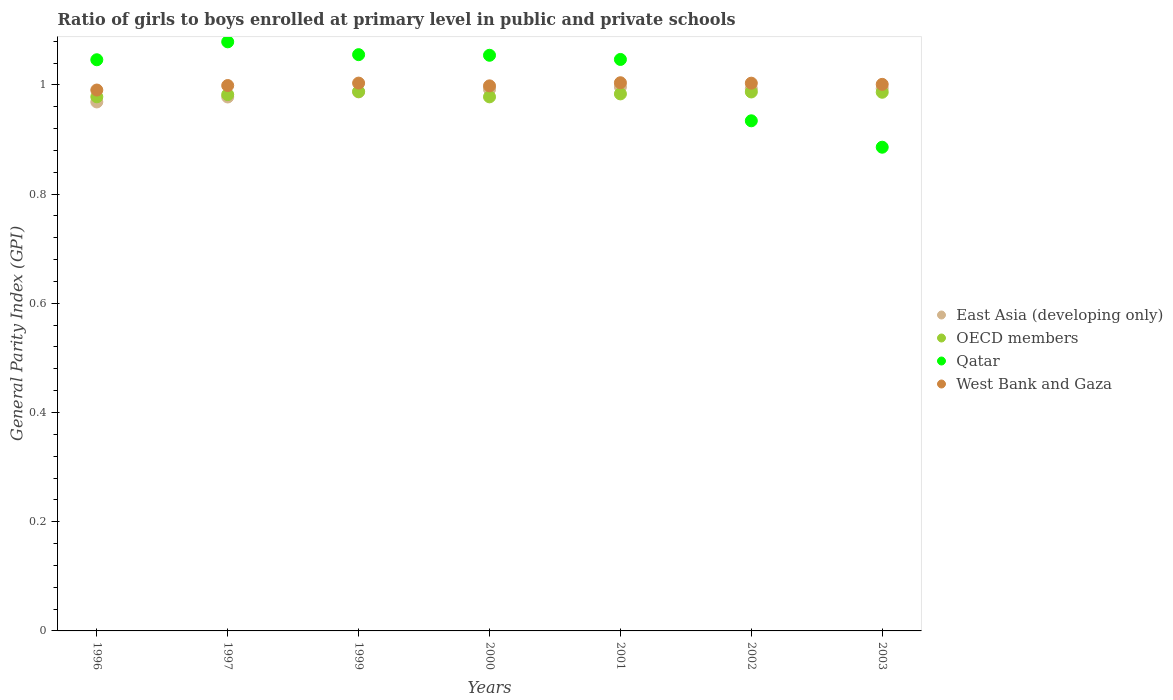How many different coloured dotlines are there?
Provide a short and direct response. 4. Is the number of dotlines equal to the number of legend labels?
Provide a short and direct response. Yes. What is the general parity index in East Asia (developing only) in 1997?
Give a very brief answer. 0.98. Across all years, what is the maximum general parity index in West Bank and Gaza?
Offer a very short reply. 1. Across all years, what is the minimum general parity index in OECD members?
Offer a terse response. 0.98. In which year was the general parity index in OECD members minimum?
Your answer should be very brief. 2000. What is the total general parity index in East Asia (developing only) in the graph?
Offer a terse response. 6.91. What is the difference between the general parity index in OECD members in 1996 and that in 2003?
Give a very brief answer. -0.01. What is the difference between the general parity index in OECD members in 1999 and the general parity index in Qatar in 2000?
Keep it short and to the point. -0.07. What is the average general parity index in Qatar per year?
Your response must be concise. 1.01. In the year 2003, what is the difference between the general parity index in OECD members and general parity index in Qatar?
Provide a short and direct response. 0.1. What is the ratio of the general parity index in Qatar in 2000 to that in 2002?
Provide a short and direct response. 1.13. Is the general parity index in Qatar in 1999 less than that in 2001?
Ensure brevity in your answer.  No. Is the difference between the general parity index in OECD members in 1999 and 2001 greater than the difference between the general parity index in Qatar in 1999 and 2001?
Your response must be concise. No. What is the difference between the highest and the second highest general parity index in East Asia (developing only)?
Give a very brief answer. 0. What is the difference between the highest and the lowest general parity index in East Asia (developing only)?
Your response must be concise. 0.03. In how many years, is the general parity index in OECD members greater than the average general parity index in OECD members taken over all years?
Offer a very short reply. 4. Is the sum of the general parity index in OECD members in 1999 and 2002 greater than the maximum general parity index in West Bank and Gaza across all years?
Provide a succinct answer. Yes. Is it the case that in every year, the sum of the general parity index in East Asia (developing only) and general parity index in Qatar  is greater than the general parity index in West Bank and Gaza?
Provide a succinct answer. Yes. Does the general parity index in West Bank and Gaza monotonically increase over the years?
Offer a terse response. No. Is the general parity index in West Bank and Gaza strictly greater than the general parity index in East Asia (developing only) over the years?
Your answer should be compact. Yes. How many years are there in the graph?
Your response must be concise. 7. What is the difference between two consecutive major ticks on the Y-axis?
Make the answer very short. 0.2. How are the legend labels stacked?
Offer a very short reply. Vertical. What is the title of the graph?
Your answer should be compact. Ratio of girls to boys enrolled at primary level in public and private schools. What is the label or title of the Y-axis?
Provide a succinct answer. General Parity Index (GPI). What is the General Parity Index (GPI) in East Asia (developing only) in 1996?
Your answer should be compact. 0.97. What is the General Parity Index (GPI) in OECD members in 1996?
Make the answer very short. 0.98. What is the General Parity Index (GPI) of Qatar in 1996?
Provide a short and direct response. 1.05. What is the General Parity Index (GPI) in West Bank and Gaza in 1996?
Keep it short and to the point. 0.99. What is the General Parity Index (GPI) in East Asia (developing only) in 1997?
Offer a terse response. 0.98. What is the General Parity Index (GPI) in OECD members in 1997?
Provide a short and direct response. 0.98. What is the General Parity Index (GPI) of Qatar in 1997?
Ensure brevity in your answer.  1.08. What is the General Parity Index (GPI) of West Bank and Gaza in 1997?
Your answer should be very brief. 1. What is the General Parity Index (GPI) in East Asia (developing only) in 1999?
Provide a succinct answer. 0.99. What is the General Parity Index (GPI) in OECD members in 1999?
Ensure brevity in your answer.  0.99. What is the General Parity Index (GPI) in Qatar in 1999?
Offer a terse response. 1.06. What is the General Parity Index (GPI) in West Bank and Gaza in 1999?
Your response must be concise. 1. What is the General Parity Index (GPI) in East Asia (developing only) in 2000?
Make the answer very short. 0.99. What is the General Parity Index (GPI) in OECD members in 2000?
Ensure brevity in your answer.  0.98. What is the General Parity Index (GPI) in Qatar in 2000?
Offer a very short reply. 1.05. What is the General Parity Index (GPI) of West Bank and Gaza in 2000?
Make the answer very short. 1. What is the General Parity Index (GPI) in East Asia (developing only) in 2001?
Offer a very short reply. 1. What is the General Parity Index (GPI) of OECD members in 2001?
Offer a terse response. 0.98. What is the General Parity Index (GPI) of Qatar in 2001?
Offer a very short reply. 1.05. What is the General Parity Index (GPI) of West Bank and Gaza in 2001?
Your answer should be compact. 1. What is the General Parity Index (GPI) in East Asia (developing only) in 2002?
Your answer should be very brief. 0.99. What is the General Parity Index (GPI) in OECD members in 2002?
Keep it short and to the point. 0.99. What is the General Parity Index (GPI) of Qatar in 2002?
Your answer should be compact. 0.93. What is the General Parity Index (GPI) in West Bank and Gaza in 2002?
Keep it short and to the point. 1. What is the General Parity Index (GPI) in East Asia (developing only) in 2003?
Your answer should be compact. 0.99. What is the General Parity Index (GPI) in OECD members in 2003?
Make the answer very short. 0.99. What is the General Parity Index (GPI) in Qatar in 2003?
Offer a terse response. 0.89. What is the General Parity Index (GPI) of West Bank and Gaza in 2003?
Make the answer very short. 1. Across all years, what is the maximum General Parity Index (GPI) in East Asia (developing only)?
Provide a succinct answer. 1. Across all years, what is the maximum General Parity Index (GPI) in OECD members?
Your answer should be compact. 0.99. Across all years, what is the maximum General Parity Index (GPI) of Qatar?
Ensure brevity in your answer.  1.08. Across all years, what is the maximum General Parity Index (GPI) of West Bank and Gaza?
Keep it short and to the point. 1. Across all years, what is the minimum General Parity Index (GPI) in East Asia (developing only)?
Offer a terse response. 0.97. Across all years, what is the minimum General Parity Index (GPI) of OECD members?
Provide a short and direct response. 0.98. Across all years, what is the minimum General Parity Index (GPI) of Qatar?
Provide a short and direct response. 0.89. Across all years, what is the minimum General Parity Index (GPI) of West Bank and Gaza?
Your answer should be compact. 0.99. What is the total General Parity Index (GPI) in East Asia (developing only) in the graph?
Give a very brief answer. 6.91. What is the total General Parity Index (GPI) in OECD members in the graph?
Make the answer very short. 6.88. What is the total General Parity Index (GPI) in Qatar in the graph?
Offer a very short reply. 7.1. What is the total General Parity Index (GPI) in West Bank and Gaza in the graph?
Give a very brief answer. 7. What is the difference between the General Parity Index (GPI) in East Asia (developing only) in 1996 and that in 1997?
Your response must be concise. -0.01. What is the difference between the General Parity Index (GPI) in OECD members in 1996 and that in 1997?
Offer a very short reply. -0. What is the difference between the General Parity Index (GPI) of Qatar in 1996 and that in 1997?
Give a very brief answer. -0.03. What is the difference between the General Parity Index (GPI) of West Bank and Gaza in 1996 and that in 1997?
Your answer should be compact. -0.01. What is the difference between the General Parity Index (GPI) in East Asia (developing only) in 1996 and that in 1999?
Offer a terse response. -0.02. What is the difference between the General Parity Index (GPI) in OECD members in 1996 and that in 1999?
Keep it short and to the point. -0.01. What is the difference between the General Parity Index (GPI) of Qatar in 1996 and that in 1999?
Your answer should be compact. -0.01. What is the difference between the General Parity Index (GPI) of West Bank and Gaza in 1996 and that in 1999?
Offer a very short reply. -0.01. What is the difference between the General Parity Index (GPI) in East Asia (developing only) in 1996 and that in 2000?
Provide a succinct answer. -0.02. What is the difference between the General Parity Index (GPI) in OECD members in 1996 and that in 2000?
Provide a short and direct response. 0. What is the difference between the General Parity Index (GPI) in Qatar in 1996 and that in 2000?
Give a very brief answer. -0.01. What is the difference between the General Parity Index (GPI) of West Bank and Gaza in 1996 and that in 2000?
Your response must be concise. -0.01. What is the difference between the General Parity Index (GPI) in East Asia (developing only) in 1996 and that in 2001?
Give a very brief answer. -0.03. What is the difference between the General Parity Index (GPI) of OECD members in 1996 and that in 2001?
Give a very brief answer. -0.01. What is the difference between the General Parity Index (GPI) of Qatar in 1996 and that in 2001?
Make the answer very short. -0. What is the difference between the General Parity Index (GPI) in West Bank and Gaza in 1996 and that in 2001?
Your answer should be very brief. -0.01. What is the difference between the General Parity Index (GPI) of East Asia (developing only) in 1996 and that in 2002?
Keep it short and to the point. -0.02. What is the difference between the General Parity Index (GPI) of OECD members in 1996 and that in 2002?
Your answer should be very brief. -0.01. What is the difference between the General Parity Index (GPI) in Qatar in 1996 and that in 2002?
Ensure brevity in your answer.  0.11. What is the difference between the General Parity Index (GPI) in West Bank and Gaza in 1996 and that in 2002?
Offer a very short reply. -0.01. What is the difference between the General Parity Index (GPI) of East Asia (developing only) in 1996 and that in 2003?
Your answer should be compact. -0.02. What is the difference between the General Parity Index (GPI) in OECD members in 1996 and that in 2003?
Keep it short and to the point. -0.01. What is the difference between the General Parity Index (GPI) in Qatar in 1996 and that in 2003?
Provide a short and direct response. 0.16. What is the difference between the General Parity Index (GPI) of West Bank and Gaza in 1996 and that in 2003?
Your response must be concise. -0.01. What is the difference between the General Parity Index (GPI) of East Asia (developing only) in 1997 and that in 1999?
Give a very brief answer. -0.01. What is the difference between the General Parity Index (GPI) of OECD members in 1997 and that in 1999?
Provide a succinct answer. -0.01. What is the difference between the General Parity Index (GPI) of Qatar in 1997 and that in 1999?
Ensure brevity in your answer.  0.02. What is the difference between the General Parity Index (GPI) in West Bank and Gaza in 1997 and that in 1999?
Keep it short and to the point. -0. What is the difference between the General Parity Index (GPI) of East Asia (developing only) in 1997 and that in 2000?
Your answer should be very brief. -0.01. What is the difference between the General Parity Index (GPI) of OECD members in 1997 and that in 2000?
Keep it short and to the point. 0. What is the difference between the General Parity Index (GPI) of Qatar in 1997 and that in 2000?
Offer a terse response. 0.02. What is the difference between the General Parity Index (GPI) of West Bank and Gaza in 1997 and that in 2000?
Offer a very short reply. 0. What is the difference between the General Parity Index (GPI) of East Asia (developing only) in 1997 and that in 2001?
Ensure brevity in your answer.  -0.02. What is the difference between the General Parity Index (GPI) of OECD members in 1997 and that in 2001?
Give a very brief answer. -0. What is the difference between the General Parity Index (GPI) of Qatar in 1997 and that in 2001?
Make the answer very short. 0.03. What is the difference between the General Parity Index (GPI) of West Bank and Gaza in 1997 and that in 2001?
Make the answer very short. -0.01. What is the difference between the General Parity Index (GPI) in East Asia (developing only) in 1997 and that in 2002?
Provide a short and direct response. -0.02. What is the difference between the General Parity Index (GPI) of OECD members in 1997 and that in 2002?
Your answer should be compact. -0. What is the difference between the General Parity Index (GPI) of Qatar in 1997 and that in 2002?
Offer a very short reply. 0.14. What is the difference between the General Parity Index (GPI) in West Bank and Gaza in 1997 and that in 2002?
Provide a short and direct response. -0. What is the difference between the General Parity Index (GPI) in East Asia (developing only) in 1997 and that in 2003?
Ensure brevity in your answer.  -0.02. What is the difference between the General Parity Index (GPI) of OECD members in 1997 and that in 2003?
Provide a succinct answer. -0. What is the difference between the General Parity Index (GPI) in Qatar in 1997 and that in 2003?
Offer a terse response. 0.19. What is the difference between the General Parity Index (GPI) in West Bank and Gaza in 1997 and that in 2003?
Your answer should be very brief. -0. What is the difference between the General Parity Index (GPI) of East Asia (developing only) in 1999 and that in 2000?
Your answer should be very brief. -0. What is the difference between the General Parity Index (GPI) in OECD members in 1999 and that in 2000?
Your response must be concise. 0.01. What is the difference between the General Parity Index (GPI) of Qatar in 1999 and that in 2000?
Offer a very short reply. 0. What is the difference between the General Parity Index (GPI) in West Bank and Gaza in 1999 and that in 2000?
Your answer should be compact. 0.01. What is the difference between the General Parity Index (GPI) of East Asia (developing only) in 1999 and that in 2001?
Make the answer very short. -0.01. What is the difference between the General Parity Index (GPI) of OECD members in 1999 and that in 2001?
Your answer should be very brief. 0. What is the difference between the General Parity Index (GPI) in Qatar in 1999 and that in 2001?
Your answer should be compact. 0.01. What is the difference between the General Parity Index (GPI) in West Bank and Gaza in 1999 and that in 2001?
Keep it short and to the point. -0. What is the difference between the General Parity Index (GPI) in East Asia (developing only) in 1999 and that in 2002?
Provide a short and direct response. -0.01. What is the difference between the General Parity Index (GPI) of OECD members in 1999 and that in 2002?
Your answer should be compact. 0. What is the difference between the General Parity Index (GPI) in Qatar in 1999 and that in 2002?
Provide a succinct answer. 0.12. What is the difference between the General Parity Index (GPI) of West Bank and Gaza in 1999 and that in 2002?
Make the answer very short. 0. What is the difference between the General Parity Index (GPI) of East Asia (developing only) in 1999 and that in 2003?
Offer a very short reply. -0.01. What is the difference between the General Parity Index (GPI) of OECD members in 1999 and that in 2003?
Provide a short and direct response. 0. What is the difference between the General Parity Index (GPI) in Qatar in 1999 and that in 2003?
Offer a terse response. 0.17. What is the difference between the General Parity Index (GPI) in West Bank and Gaza in 1999 and that in 2003?
Provide a short and direct response. 0. What is the difference between the General Parity Index (GPI) in East Asia (developing only) in 2000 and that in 2001?
Give a very brief answer. -0. What is the difference between the General Parity Index (GPI) in OECD members in 2000 and that in 2001?
Keep it short and to the point. -0.01. What is the difference between the General Parity Index (GPI) of Qatar in 2000 and that in 2001?
Your response must be concise. 0.01. What is the difference between the General Parity Index (GPI) in West Bank and Gaza in 2000 and that in 2001?
Your answer should be very brief. -0.01. What is the difference between the General Parity Index (GPI) in East Asia (developing only) in 2000 and that in 2002?
Your response must be concise. -0. What is the difference between the General Parity Index (GPI) in OECD members in 2000 and that in 2002?
Your response must be concise. -0.01. What is the difference between the General Parity Index (GPI) in Qatar in 2000 and that in 2002?
Offer a very short reply. 0.12. What is the difference between the General Parity Index (GPI) of West Bank and Gaza in 2000 and that in 2002?
Your answer should be compact. -0. What is the difference between the General Parity Index (GPI) in East Asia (developing only) in 2000 and that in 2003?
Your answer should be very brief. -0. What is the difference between the General Parity Index (GPI) in OECD members in 2000 and that in 2003?
Offer a terse response. -0.01. What is the difference between the General Parity Index (GPI) in Qatar in 2000 and that in 2003?
Your answer should be very brief. 0.17. What is the difference between the General Parity Index (GPI) of West Bank and Gaza in 2000 and that in 2003?
Ensure brevity in your answer.  -0. What is the difference between the General Parity Index (GPI) of East Asia (developing only) in 2001 and that in 2002?
Your answer should be very brief. 0. What is the difference between the General Parity Index (GPI) of OECD members in 2001 and that in 2002?
Your response must be concise. -0. What is the difference between the General Parity Index (GPI) in Qatar in 2001 and that in 2002?
Keep it short and to the point. 0.11. What is the difference between the General Parity Index (GPI) of West Bank and Gaza in 2001 and that in 2002?
Your answer should be very brief. 0. What is the difference between the General Parity Index (GPI) of East Asia (developing only) in 2001 and that in 2003?
Ensure brevity in your answer.  0. What is the difference between the General Parity Index (GPI) in OECD members in 2001 and that in 2003?
Keep it short and to the point. -0. What is the difference between the General Parity Index (GPI) of Qatar in 2001 and that in 2003?
Keep it short and to the point. 0.16. What is the difference between the General Parity Index (GPI) of West Bank and Gaza in 2001 and that in 2003?
Give a very brief answer. 0. What is the difference between the General Parity Index (GPI) in East Asia (developing only) in 2002 and that in 2003?
Provide a short and direct response. -0. What is the difference between the General Parity Index (GPI) of OECD members in 2002 and that in 2003?
Give a very brief answer. 0. What is the difference between the General Parity Index (GPI) of Qatar in 2002 and that in 2003?
Offer a very short reply. 0.05. What is the difference between the General Parity Index (GPI) in West Bank and Gaza in 2002 and that in 2003?
Provide a succinct answer. 0. What is the difference between the General Parity Index (GPI) in East Asia (developing only) in 1996 and the General Parity Index (GPI) in OECD members in 1997?
Your answer should be very brief. -0.01. What is the difference between the General Parity Index (GPI) in East Asia (developing only) in 1996 and the General Parity Index (GPI) in Qatar in 1997?
Offer a terse response. -0.11. What is the difference between the General Parity Index (GPI) of East Asia (developing only) in 1996 and the General Parity Index (GPI) of West Bank and Gaza in 1997?
Offer a very short reply. -0.03. What is the difference between the General Parity Index (GPI) of OECD members in 1996 and the General Parity Index (GPI) of Qatar in 1997?
Ensure brevity in your answer.  -0.1. What is the difference between the General Parity Index (GPI) of OECD members in 1996 and the General Parity Index (GPI) of West Bank and Gaza in 1997?
Offer a terse response. -0.02. What is the difference between the General Parity Index (GPI) in Qatar in 1996 and the General Parity Index (GPI) in West Bank and Gaza in 1997?
Make the answer very short. 0.05. What is the difference between the General Parity Index (GPI) of East Asia (developing only) in 1996 and the General Parity Index (GPI) of OECD members in 1999?
Ensure brevity in your answer.  -0.02. What is the difference between the General Parity Index (GPI) of East Asia (developing only) in 1996 and the General Parity Index (GPI) of Qatar in 1999?
Your response must be concise. -0.09. What is the difference between the General Parity Index (GPI) in East Asia (developing only) in 1996 and the General Parity Index (GPI) in West Bank and Gaza in 1999?
Offer a terse response. -0.03. What is the difference between the General Parity Index (GPI) in OECD members in 1996 and the General Parity Index (GPI) in Qatar in 1999?
Ensure brevity in your answer.  -0.08. What is the difference between the General Parity Index (GPI) of OECD members in 1996 and the General Parity Index (GPI) of West Bank and Gaza in 1999?
Keep it short and to the point. -0.03. What is the difference between the General Parity Index (GPI) in Qatar in 1996 and the General Parity Index (GPI) in West Bank and Gaza in 1999?
Your answer should be very brief. 0.04. What is the difference between the General Parity Index (GPI) in East Asia (developing only) in 1996 and the General Parity Index (GPI) in OECD members in 2000?
Provide a succinct answer. -0.01. What is the difference between the General Parity Index (GPI) of East Asia (developing only) in 1996 and the General Parity Index (GPI) of Qatar in 2000?
Make the answer very short. -0.09. What is the difference between the General Parity Index (GPI) in East Asia (developing only) in 1996 and the General Parity Index (GPI) in West Bank and Gaza in 2000?
Keep it short and to the point. -0.03. What is the difference between the General Parity Index (GPI) in OECD members in 1996 and the General Parity Index (GPI) in Qatar in 2000?
Offer a very short reply. -0.08. What is the difference between the General Parity Index (GPI) of OECD members in 1996 and the General Parity Index (GPI) of West Bank and Gaza in 2000?
Provide a short and direct response. -0.02. What is the difference between the General Parity Index (GPI) of Qatar in 1996 and the General Parity Index (GPI) of West Bank and Gaza in 2000?
Your answer should be compact. 0.05. What is the difference between the General Parity Index (GPI) in East Asia (developing only) in 1996 and the General Parity Index (GPI) in OECD members in 2001?
Make the answer very short. -0.01. What is the difference between the General Parity Index (GPI) in East Asia (developing only) in 1996 and the General Parity Index (GPI) in Qatar in 2001?
Offer a very short reply. -0.08. What is the difference between the General Parity Index (GPI) of East Asia (developing only) in 1996 and the General Parity Index (GPI) of West Bank and Gaza in 2001?
Keep it short and to the point. -0.04. What is the difference between the General Parity Index (GPI) of OECD members in 1996 and the General Parity Index (GPI) of Qatar in 2001?
Your answer should be compact. -0.07. What is the difference between the General Parity Index (GPI) in OECD members in 1996 and the General Parity Index (GPI) in West Bank and Gaza in 2001?
Your response must be concise. -0.03. What is the difference between the General Parity Index (GPI) of Qatar in 1996 and the General Parity Index (GPI) of West Bank and Gaza in 2001?
Offer a terse response. 0.04. What is the difference between the General Parity Index (GPI) of East Asia (developing only) in 1996 and the General Parity Index (GPI) of OECD members in 2002?
Provide a succinct answer. -0.02. What is the difference between the General Parity Index (GPI) of East Asia (developing only) in 1996 and the General Parity Index (GPI) of Qatar in 2002?
Make the answer very short. 0.03. What is the difference between the General Parity Index (GPI) in East Asia (developing only) in 1996 and the General Parity Index (GPI) in West Bank and Gaza in 2002?
Make the answer very short. -0.03. What is the difference between the General Parity Index (GPI) of OECD members in 1996 and the General Parity Index (GPI) of Qatar in 2002?
Your answer should be compact. 0.04. What is the difference between the General Parity Index (GPI) in OECD members in 1996 and the General Parity Index (GPI) in West Bank and Gaza in 2002?
Offer a very short reply. -0.03. What is the difference between the General Parity Index (GPI) of Qatar in 1996 and the General Parity Index (GPI) of West Bank and Gaza in 2002?
Provide a succinct answer. 0.04. What is the difference between the General Parity Index (GPI) of East Asia (developing only) in 1996 and the General Parity Index (GPI) of OECD members in 2003?
Keep it short and to the point. -0.02. What is the difference between the General Parity Index (GPI) in East Asia (developing only) in 1996 and the General Parity Index (GPI) in Qatar in 2003?
Ensure brevity in your answer.  0.08. What is the difference between the General Parity Index (GPI) in East Asia (developing only) in 1996 and the General Parity Index (GPI) in West Bank and Gaza in 2003?
Give a very brief answer. -0.03. What is the difference between the General Parity Index (GPI) in OECD members in 1996 and the General Parity Index (GPI) in Qatar in 2003?
Provide a short and direct response. 0.09. What is the difference between the General Parity Index (GPI) in OECD members in 1996 and the General Parity Index (GPI) in West Bank and Gaza in 2003?
Provide a succinct answer. -0.02. What is the difference between the General Parity Index (GPI) in Qatar in 1996 and the General Parity Index (GPI) in West Bank and Gaza in 2003?
Your answer should be very brief. 0.05. What is the difference between the General Parity Index (GPI) in East Asia (developing only) in 1997 and the General Parity Index (GPI) in OECD members in 1999?
Your answer should be compact. -0.01. What is the difference between the General Parity Index (GPI) in East Asia (developing only) in 1997 and the General Parity Index (GPI) in Qatar in 1999?
Your answer should be compact. -0.08. What is the difference between the General Parity Index (GPI) in East Asia (developing only) in 1997 and the General Parity Index (GPI) in West Bank and Gaza in 1999?
Ensure brevity in your answer.  -0.03. What is the difference between the General Parity Index (GPI) of OECD members in 1997 and the General Parity Index (GPI) of Qatar in 1999?
Keep it short and to the point. -0.07. What is the difference between the General Parity Index (GPI) in OECD members in 1997 and the General Parity Index (GPI) in West Bank and Gaza in 1999?
Provide a short and direct response. -0.02. What is the difference between the General Parity Index (GPI) in Qatar in 1997 and the General Parity Index (GPI) in West Bank and Gaza in 1999?
Give a very brief answer. 0.08. What is the difference between the General Parity Index (GPI) in East Asia (developing only) in 1997 and the General Parity Index (GPI) in OECD members in 2000?
Give a very brief answer. -0. What is the difference between the General Parity Index (GPI) in East Asia (developing only) in 1997 and the General Parity Index (GPI) in Qatar in 2000?
Offer a very short reply. -0.08. What is the difference between the General Parity Index (GPI) of East Asia (developing only) in 1997 and the General Parity Index (GPI) of West Bank and Gaza in 2000?
Give a very brief answer. -0.02. What is the difference between the General Parity Index (GPI) of OECD members in 1997 and the General Parity Index (GPI) of Qatar in 2000?
Keep it short and to the point. -0.07. What is the difference between the General Parity Index (GPI) in OECD members in 1997 and the General Parity Index (GPI) in West Bank and Gaza in 2000?
Give a very brief answer. -0.02. What is the difference between the General Parity Index (GPI) of Qatar in 1997 and the General Parity Index (GPI) of West Bank and Gaza in 2000?
Give a very brief answer. 0.08. What is the difference between the General Parity Index (GPI) of East Asia (developing only) in 1997 and the General Parity Index (GPI) of OECD members in 2001?
Offer a very short reply. -0.01. What is the difference between the General Parity Index (GPI) in East Asia (developing only) in 1997 and the General Parity Index (GPI) in Qatar in 2001?
Your response must be concise. -0.07. What is the difference between the General Parity Index (GPI) in East Asia (developing only) in 1997 and the General Parity Index (GPI) in West Bank and Gaza in 2001?
Offer a terse response. -0.03. What is the difference between the General Parity Index (GPI) of OECD members in 1997 and the General Parity Index (GPI) of Qatar in 2001?
Your answer should be very brief. -0.06. What is the difference between the General Parity Index (GPI) in OECD members in 1997 and the General Parity Index (GPI) in West Bank and Gaza in 2001?
Your answer should be compact. -0.02. What is the difference between the General Parity Index (GPI) in Qatar in 1997 and the General Parity Index (GPI) in West Bank and Gaza in 2001?
Make the answer very short. 0.07. What is the difference between the General Parity Index (GPI) of East Asia (developing only) in 1997 and the General Parity Index (GPI) of OECD members in 2002?
Give a very brief answer. -0.01. What is the difference between the General Parity Index (GPI) of East Asia (developing only) in 1997 and the General Parity Index (GPI) of Qatar in 2002?
Offer a very short reply. 0.04. What is the difference between the General Parity Index (GPI) of East Asia (developing only) in 1997 and the General Parity Index (GPI) of West Bank and Gaza in 2002?
Give a very brief answer. -0.03. What is the difference between the General Parity Index (GPI) in OECD members in 1997 and the General Parity Index (GPI) in Qatar in 2002?
Keep it short and to the point. 0.05. What is the difference between the General Parity Index (GPI) in OECD members in 1997 and the General Parity Index (GPI) in West Bank and Gaza in 2002?
Your answer should be very brief. -0.02. What is the difference between the General Parity Index (GPI) in Qatar in 1997 and the General Parity Index (GPI) in West Bank and Gaza in 2002?
Your answer should be very brief. 0.08. What is the difference between the General Parity Index (GPI) in East Asia (developing only) in 1997 and the General Parity Index (GPI) in OECD members in 2003?
Your response must be concise. -0.01. What is the difference between the General Parity Index (GPI) of East Asia (developing only) in 1997 and the General Parity Index (GPI) of Qatar in 2003?
Make the answer very short. 0.09. What is the difference between the General Parity Index (GPI) in East Asia (developing only) in 1997 and the General Parity Index (GPI) in West Bank and Gaza in 2003?
Offer a very short reply. -0.02. What is the difference between the General Parity Index (GPI) of OECD members in 1997 and the General Parity Index (GPI) of Qatar in 2003?
Your answer should be very brief. 0.1. What is the difference between the General Parity Index (GPI) in OECD members in 1997 and the General Parity Index (GPI) in West Bank and Gaza in 2003?
Offer a very short reply. -0.02. What is the difference between the General Parity Index (GPI) in Qatar in 1997 and the General Parity Index (GPI) in West Bank and Gaza in 2003?
Provide a short and direct response. 0.08. What is the difference between the General Parity Index (GPI) of East Asia (developing only) in 1999 and the General Parity Index (GPI) of OECD members in 2000?
Offer a very short reply. 0.01. What is the difference between the General Parity Index (GPI) of East Asia (developing only) in 1999 and the General Parity Index (GPI) of Qatar in 2000?
Give a very brief answer. -0.07. What is the difference between the General Parity Index (GPI) of East Asia (developing only) in 1999 and the General Parity Index (GPI) of West Bank and Gaza in 2000?
Provide a short and direct response. -0.01. What is the difference between the General Parity Index (GPI) of OECD members in 1999 and the General Parity Index (GPI) of Qatar in 2000?
Your answer should be very brief. -0.07. What is the difference between the General Parity Index (GPI) in OECD members in 1999 and the General Parity Index (GPI) in West Bank and Gaza in 2000?
Your answer should be very brief. -0.01. What is the difference between the General Parity Index (GPI) of Qatar in 1999 and the General Parity Index (GPI) of West Bank and Gaza in 2000?
Give a very brief answer. 0.06. What is the difference between the General Parity Index (GPI) in East Asia (developing only) in 1999 and the General Parity Index (GPI) in OECD members in 2001?
Keep it short and to the point. 0. What is the difference between the General Parity Index (GPI) of East Asia (developing only) in 1999 and the General Parity Index (GPI) of Qatar in 2001?
Provide a short and direct response. -0.06. What is the difference between the General Parity Index (GPI) of East Asia (developing only) in 1999 and the General Parity Index (GPI) of West Bank and Gaza in 2001?
Your answer should be compact. -0.02. What is the difference between the General Parity Index (GPI) of OECD members in 1999 and the General Parity Index (GPI) of Qatar in 2001?
Offer a terse response. -0.06. What is the difference between the General Parity Index (GPI) of OECD members in 1999 and the General Parity Index (GPI) of West Bank and Gaza in 2001?
Provide a succinct answer. -0.02. What is the difference between the General Parity Index (GPI) in Qatar in 1999 and the General Parity Index (GPI) in West Bank and Gaza in 2001?
Make the answer very short. 0.05. What is the difference between the General Parity Index (GPI) in East Asia (developing only) in 1999 and the General Parity Index (GPI) in OECD members in 2002?
Offer a very short reply. 0. What is the difference between the General Parity Index (GPI) in East Asia (developing only) in 1999 and the General Parity Index (GPI) in Qatar in 2002?
Your answer should be very brief. 0.05. What is the difference between the General Parity Index (GPI) of East Asia (developing only) in 1999 and the General Parity Index (GPI) of West Bank and Gaza in 2002?
Give a very brief answer. -0.02. What is the difference between the General Parity Index (GPI) in OECD members in 1999 and the General Parity Index (GPI) in Qatar in 2002?
Your response must be concise. 0.05. What is the difference between the General Parity Index (GPI) in OECD members in 1999 and the General Parity Index (GPI) in West Bank and Gaza in 2002?
Your response must be concise. -0.02. What is the difference between the General Parity Index (GPI) in Qatar in 1999 and the General Parity Index (GPI) in West Bank and Gaza in 2002?
Give a very brief answer. 0.05. What is the difference between the General Parity Index (GPI) in East Asia (developing only) in 1999 and the General Parity Index (GPI) in OECD members in 2003?
Offer a terse response. 0. What is the difference between the General Parity Index (GPI) in East Asia (developing only) in 1999 and the General Parity Index (GPI) in Qatar in 2003?
Provide a short and direct response. 0.1. What is the difference between the General Parity Index (GPI) of East Asia (developing only) in 1999 and the General Parity Index (GPI) of West Bank and Gaza in 2003?
Your response must be concise. -0.01. What is the difference between the General Parity Index (GPI) of OECD members in 1999 and the General Parity Index (GPI) of Qatar in 2003?
Your answer should be very brief. 0.1. What is the difference between the General Parity Index (GPI) in OECD members in 1999 and the General Parity Index (GPI) in West Bank and Gaza in 2003?
Make the answer very short. -0.01. What is the difference between the General Parity Index (GPI) in Qatar in 1999 and the General Parity Index (GPI) in West Bank and Gaza in 2003?
Provide a short and direct response. 0.05. What is the difference between the General Parity Index (GPI) in East Asia (developing only) in 2000 and the General Parity Index (GPI) in OECD members in 2001?
Make the answer very short. 0.01. What is the difference between the General Parity Index (GPI) of East Asia (developing only) in 2000 and the General Parity Index (GPI) of Qatar in 2001?
Provide a succinct answer. -0.05. What is the difference between the General Parity Index (GPI) in East Asia (developing only) in 2000 and the General Parity Index (GPI) in West Bank and Gaza in 2001?
Offer a terse response. -0.01. What is the difference between the General Parity Index (GPI) of OECD members in 2000 and the General Parity Index (GPI) of Qatar in 2001?
Make the answer very short. -0.07. What is the difference between the General Parity Index (GPI) of OECD members in 2000 and the General Parity Index (GPI) of West Bank and Gaza in 2001?
Your answer should be compact. -0.03. What is the difference between the General Parity Index (GPI) of Qatar in 2000 and the General Parity Index (GPI) of West Bank and Gaza in 2001?
Give a very brief answer. 0.05. What is the difference between the General Parity Index (GPI) of East Asia (developing only) in 2000 and the General Parity Index (GPI) of OECD members in 2002?
Ensure brevity in your answer.  0. What is the difference between the General Parity Index (GPI) in East Asia (developing only) in 2000 and the General Parity Index (GPI) in Qatar in 2002?
Your response must be concise. 0.06. What is the difference between the General Parity Index (GPI) in East Asia (developing only) in 2000 and the General Parity Index (GPI) in West Bank and Gaza in 2002?
Give a very brief answer. -0.01. What is the difference between the General Parity Index (GPI) in OECD members in 2000 and the General Parity Index (GPI) in Qatar in 2002?
Keep it short and to the point. 0.04. What is the difference between the General Parity Index (GPI) in OECD members in 2000 and the General Parity Index (GPI) in West Bank and Gaza in 2002?
Keep it short and to the point. -0.03. What is the difference between the General Parity Index (GPI) of Qatar in 2000 and the General Parity Index (GPI) of West Bank and Gaza in 2002?
Keep it short and to the point. 0.05. What is the difference between the General Parity Index (GPI) of East Asia (developing only) in 2000 and the General Parity Index (GPI) of OECD members in 2003?
Make the answer very short. 0.01. What is the difference between the General Parity Index (GPI) in East Asia (developing only) in 2000 and the General Parity Index (GPI) in Qatar in 2003?
Your response must be concise. 0.11. What is the difference between the General Parity Index (GPI) in East Asia (developing only) in 2000 and the General Parity Index (GPI) in West Bank and Gaza in 2003?
Provide a short and direct response. -0.01. What is the difference between the General Parity Index (GPI) of OECD members in 2000 and the General Parity Index (GPI) of Qatar in 2003?
Your response must be concise. 0.09. What is the difference between the General Parity Index (GPI) of OECD members in 2000 and the General Parity Index (GPI) of West Bank and Gaza in 2003?
Offer a terse response. -0.02. What is the difference between the General Parity Index (GPI) in Qatar in 2000 and the General Parity Index (GPI) in West Bank and Gaza in 2003?
Ensure brevity in your answer.  0.05. What is the difference between the General Parity Index (GPI) in East Asia (developing only) in 2001 and the General Parity Index (GPI) in OECD members in 2002?
Your response must be concise. 0.01. What is the difference between the General Parity Index (GPI) in East Asia (developing only) in 2001 and the General Parity Index (GPI) in Qatar in 2002?
Ensure brevity in your answer.  0.06. What is the difference between the General Parity Index (GPI) of East Asia (developing only) in 2001 and the General Parity Index (GPI) of West Bank and Gaza in 2002?
Provide a succinct answer. -0.01. What is the difference between the General Parity Index (GPI) in OECD members in 2001 and the General Parity Index (GPI) in Qatar in 2002?
Give a very brief answer. 0.05. What is the difference between the General Parity Index (GPI) of OECD members in 2001 and the General Parity Index (GPI) of West Bank and Gaza in 2002?
Your answer should be compact. -0.02. What is the difference between the General Parity Index (GPI) of Qatar in 2001 and the General Parity Index (GPI) of West Bank and Gaza in 2002?
Offer a very short reply. 0.04. What is the difference between the General Parity Index (GPI) in East Asia (developing only) in 2001 and the General Parity Index (GPI) in OECD members in 2003?
Offer a terse response. 0.01. What is the difference between the General Parity Index (GPI) in East Asia (developing only) in 2001 and the General Parity Index (GPI) in Qatar in 2003?
Ensure brevity in your answer.  0.11. What is the difference between the General Parity Index (GPI) of East Asia (developing only) in 2001 and the General Parity Index (GPI) of West Bank and Gaza in 2003?
Ensure brevity in your answer.  -0. What is the difference between the General Parity Index (GPI) of OECD members in 2001 and the General Parity Index (GPI) of Qatar in 2003?
Ensure brevity in your answer.  0.1. What is the difference between the General Parity Index (GPI) of OECD members in 2001 and the General Parity Index (GPI) of West Bank and Gaza in 2003?
Ensure brevity in your answer.  -0.02. What is the difference between the General Parity Index (GPI) in Qatar in 2001 and the General Parity Index (GPI) in West Bank and Gaza in 2003?
Offer a very short reply. 0.05. What is the difference between the General Parity Index (GPI) of East Asia (developing only) in 2002 and the General Parity Index (GPI) of OECD members in 2003?
Keep it short and to the point. 0.01. What is the difference between the General Parity Index (GPI) of East Asia (developing only) in 2002 and the General Parity Index (GPI) of Qatar in 2003?
Ensure brevity in your answer.  0.11. What is the difference between the General Parity Index (GPI) of East Asia (developing only) in 2002 and the General Parity Index (GPI) of West Bank and Gaza in 2003?
Your response must be concise. -0.01. What is the difference between the General Parity Index (GPI) of OECD members in 2002 and the General Parity Index (GPI) of Qatar in 2003?
Give a very brief answer. 0.1. What is the difference between the General Parity Index (GPI) in OECD members in 2002 and the General Parity Index (GPI) in West Bank and Gaza in 2003?
Your response must be concise. -0.01. What is the difference between the General Parity Index (GPI) of Qatar in 2002 and the General Parity Index (GPI) of West Bank and Gaza in 2003?
Your answer should be compact. -0.07. What is the average General Parity Index (GPI) of East Asia (developing only) per year?
Your response must be concise. 0.99. What is the average General Parity Index (GPI) of OECD members per year?
Your response must be concise. 0.98. What is the average General Parity Index (GPI) of Qatar per year?
Make the answer very short. 1.01. What is the average General Parity Index (GPI) of West Bank and Gaza per year?
Offer a very short reply. 1. In the year 1996, what is the difference between the General Parity Index (GPI) of East Asia (developing only) and General Parity Index (GPI) of OECD members?
Ensure brevity in your answer.  -0.01. In the year 1996, what is the difference between the General Parity Index (GPI) in East Asia (developing only) and General Parity Index (GPI) in Qatar?
Your answer should be compact. -0.08. In the year 1996, what is the difference between the General Parity Index (GPI) in East Asia (developing only) and General Parity Index (GPI) in West Bank and Gaza?
Make the answer very short. -0.02. In the year 1996, what is the difference between the General Parity Index (GPI) in OECD members and General Parity Index (GPI) in Qatar?
Provide a succinct answer. -0.07. In the year 1996, what is the difference between the General Parity Index (GPI) of OECD members and General Parity Index (GPI) of West Bank and Gaza?
Make the answer very short. -0.01. In the year 1996, what is the difference between the General Parity Index (GPI) in Qatar and General Parity Index (GPI) in West Bank and Gaza?
Your answer should be compact. 0.06. In the year 1997, what is the difference between the General Parity Index (GPI) of East Asia (developing only) and General Parity Index (GPI) of OECD members?
Keep it short and to the point. -0. In the year 1997, what is the difference between the General Parity Index (GPI) of East Asia (developing only) and General Parity Index (GPI) of Qatar?
Your answer should be compact. -0.1. In the year 1997, what is the difference between the General Parity Index (GPI) in East Asia (developing only) and General Parity Index (GPI) in West Bank and Gaza?
Your answer should be very brief. -0.02. In the year 1997, what is the difference between the General Parity Index (GPI) in OECD members and General Parity Index (GPI) in Qatar?
Keep it short and to the point. -0.1. In the year 1997, what is the difference between the General Parity Index (GPI) in OECD members and General Parity Index (GPI) in West Bank and Gaza?
Offer a very short reply. -0.02. In the year 1999, what is the difference between the General Parity Index (GPI) in East Asia (developing only) and General Parity Index (GPI) in OECD members?
Provide a short and direct response. -0. In the year 1999, what is the difference between the General Parity Index (GPI) in East Asia (developing only) and General Parity Index (GPI) in Qatar?
Your answer should be compact. -0.07. In the year 1999, what is the difference between the General Parity Index (GPI) in East Asia (developing only) and General Parity Index (GPI) in West Bank and Gaza?
Ensure brevity in your answer.  -0.02. In the year 1999, what is the difference between the General Parity Index (GPI) of OECD members and General Parity Index (GPI) of Qatar?
Ensure brevity in your answer.  -0.07. In the year 1999, what is the difference between the General Parity Index (GPI) in OECD members and General Parity Index (GPI) in West Bank and Gaza?
Give a very brief answer. -0.02. In the year 1999, what is the difference between the General Parity Index (GPI) of Qatar and General Parity Index (GPI) of West Bank and Gaza?
Your answer should be compact. 0.05. In the year 2000, what is the difference between the General Parity Index (GPI) of East Asia (developing only) and General Parity Index (GPI) of OECD members?
Keep it short and to the point. 0.01. In the year 2000, what is the difference between the General Parity Index (GPI) in East Asia (developing only) and General Parity Index (GPI) in Qatar?
Keep it short and to the point. -0.06. In the year 2000, what is the difference between the General Parity Index (GPI) of East Asia (developing only) and General Parity Index (GPI) of West Bank and Gaza?
Provide a short and direct response. -0.01. In the year 2000, what is the difference between the General Parity Index (GPI) in OECD members and General Parity Index (GPI) in Qatar?
Your answer should be compact. -0.08. In the year 2000, what is the difference between the General Parity Index (GPI) in OECD members and General Parity Index (GPI) in West Bank and Gaza?
Provide a short and direct response. -0.02. In the year 2000, what is the difference between the General Parity Index (GPI) in Qatar and General Parity Index (GPI) in West Bank and Gaza?
Offer a terse response. 0.06. In the year 2001, what is the difference between the General Parity Index (GPI) of East Asia (developing only) and General Parity Index (GPI) of OECD members?
Make the answer very short. 0.01. In the year 2001, what is the difference between the General Parity Index (GPI) of East Asia (developing only) and General Parity Index (GPI) of Qatar?
Make the answer very short. -0.05. In the year 2001, what is the difference between the General Parity Index (GPI) of East Asia (developing only) and General Parity Index (GPI) of West Bank and Gaza?
Provide a succinct answer. -0.01. In the year 2001, what is the difference between the General Parity Index (GPI) in OECD members and General Parity Index (GPI) in Qatar?
Keep it short and to the point. -0.06. In the year 2001, what is the difference between the General Parity Index (GPI) of OECD members and General Parity Index (GPI) of West Bank and Gaza?
Provide a succinct answer. -0.02. In the year 2001, what is the difference between the General Parity Index (GPI) of Qatar and General Parity Index (GPI) of West Bank and Gaza?
Give a very brief answer. 0.04. In the year 2002, what is the difference between the General Parity Index (GPI) in East Asia (developing only) and General Parity Index (GPI) in OECD members?
Your answer should be compact. 0.01. In the year 2002, what is the difference between the General Parity Index (GPI) in East Asia (developing only) and General Parity Index (GPI) in Qatar?
Keep it short and to the point. 0.06. In the year 2002, what is the difference between the General Parity Index (GPI) of East Asia (developing only) and General Parity Index (GPI) of West Bank and Gaza?
Give a very brief answer. -0.01. In the year 2002, what is the difference between the General Parity Index (GPI) in OECD members and General Parity Index (GPI) in Qatar?
Provide a short and direct response. 0.05. In the year 2002, what is the difference between the General Parity Index (GPI) of OECD members and General Parity Index (GPI) of West Bank and Gaza?
Provide a succinct answer. -0.02. In the year 2002, what is the difference between the General Parity Index (GPI) in Qatar and General Parity Index (GPI) in West Bank and Gaza?
Your response must be concise. -0.07. In the year 2003, what is the difference between the General Parity Index (GPI) of East Asia (developing only) and General Parity Index (GPI) of OECD members?
Provide a succinct answer. 0.01. In the year 2003, what is the difference between the General Parity Index (GPI) of East Asia (developing only) and General Parity Index (GPI) of Qatar?
Keep it short and to the point. 0.11. In the year 2003, what is the difference between the General Parity Index (GPI) of East Asia (developing only) and General Parity Index (GPI) of West Bank and Gaza?
Provide a short and direct response. -0.01. In the year 2003, what is the difference between the General Parity Index (GPI) in OECD members and General Parity Index (GPI) in Qatar?
Ensure brevity in your answer.  0.1. In the year 2003, what is the difference between the General Parity Index (GPI) of OECD members and General Parity Index (GPI) of West Bank and Gaza?
Your response must be concise. -0.01. In the year 2003, what is the difference between the General Parity Index (GPI) in Qatar and General Parity Index (GPI) in West Bank and Gaza?
Give a very brief answer. -0.12. What is the ratio of the General Parity Index (GPI) in East Asia (developing only) in 1996 to that in 1997?
Ensure brevity in your answer.  0.99. What is the ratio of the General Parity Index (GPI) of OECD members in 1996 to that in 1997?
Give a very brief answer. 1. What is the ratio of the General Parity Index (GPI) of Qatar in 1996 to that in 1997?
Provide a short and direct response. 0.97. What is the ratio of the General Parity Index (GPI) in East Asia (developing only) in 1996 to that in 1999?
Your response must be concise. 0.98. What is the ratio of the General Parity Index (GPI) of OECD members in 1996 to that in 1999?
Make the answer very short. 0.99. What is the ratio of the General Parity Index (GPI) in Qatar in 1996 to that in 1999?
Provide a short and direct response. 0.99. What is the ratio of the General Parity Index (GPI) of West Bank and Gaza in 1996 to that in 1999?
Make the answer very short. 0.99. What is the ratio of the General Parity Index (GPI) in East Asia (developing only) in 1996 to that in 2000?
Give a very brief answer. 0.98. What is the ratio of the General Parity Index (GPI) in OECD members in 1996 to that in 2000?
Your answer should be very brief. 1. What is the ratio of the General Parity Index (GPI) in West Bank and Gaza in 1996 to that in 2000?
Your answer should be very brief. 0.99. What is the ratio of the General Parity Index (GPI) of East Asia (developing only) in 1996 to that in 2001?
Provide a short and direct response. 0.97. What is the ratio of the General Parity Index (GPI) in OECD members in 1996 to that in 2001?
Make the answer very short. 0.99. What is the ratio of the General Parity Index (GPI) of Qatar in 1996 to that in 2001?
Give a very brief answer. 1. What is the ratio of the General Parity Index (GPI) in West Bank and Gaza in 1996 to that in 2001?
Provide a short and direct response. 0.99. What is the ratio of the General Parity Index (GPI) in East Asia (developing only) in 1996 to that in 2002?
Your answer should be compact. 0.98. What is the ratio of the General Parity Index (GPI) of OECD members in 1996 to that in 2002?
Your answer should be compact. 0.99. What is the ratio of the General Parity Index (GPI) in Qatar in 1996 to that in 2002?
Provide a succinct answer. 1.12. What is the ratio of the General Parity Index (GPI) of West Bank and Gaza in 1996 to that in 2002?
Provide a short and direct response. 0.99. What is the ratio of the General Parity Index (GPI) of East Asia (developing only) in 1996 to that in 2003?
Your response must be concise. 0.98. What is the ratio of the General Parity Index (GPI) in Qatar in 1996 to that in 2003?
Offer a very short reply. 1.18. What is the ratio of the General Parity Index (GPI) of West Bank and Gaza in 1996 to that in 2003?
Your answer should be very brief. 0.99. What is the ratio of the General Parity Index (GPI) in OECD members in 1997 to that in 1999?
Provide a succinct answer. 0.99. What is the ratio of the General Parity Index (GPI) in Qatar in 1997 to that in 1999?
Provide a succinct answer. 1.02. What is the ratio of the General Parity Index (GPI) of West Bank and Gaza in 1997 to that in 1999?
Your answer should be compact. 1. What is the ratio of the General Parity Index (GPI) of East Asia (developing only) in 1997 to that in 2000?
Offer a very short reply. 0.99. What is the ratio of the General Parity Index (GPI) of Qatar in 1997 to that in 2000?
Make the answer very short. 1.02. What is the ratio of the General Parity Index (GPI) in West Bank and Gaza in 1997 to that in 2000?
Your answer should be very brief. 1. What is the ratio of the General Parity Index (GPI) in East Asia (developing only) in 1997 to that in 2001?
Give a very brief answer. 0.98. What is the ratio of the General Parity Index (GPI) in OECD members in 1997 to that in 2001?
Your response must be concise. 1. What is the ratio of the General Parity Index (GPI) of Qatar in 1997 to that in 2001?
Provide a short and direct response. 1.03. What is the ratio of the General Parity Index (GPI) of East Asia (developing only) in 1997 to that in 2002?
Give a very brief answer. 0.98. What is the ratio of the General Parity Index (GPI) in Qatar in 1997 to that in 2002?
Give a very brief answer. 1.15. What is the ratio of the General Parity Index (GPI) in East Asia (developing only) in 1997 to that in 2003?
Keep it short and to the point. 0.98. What is the ratio of the General Parity Index (GPI) of OECD members in 1997 to that in 2003?
Offer a very short reply. 1. What is the ratio of the General Parity Index (GPI) of Qatar in 1997 to that in 2003?
Ensure brevity in your answer.  1.22. What is the ratio of the General Parity Index (GPI) in West Bank and Gaza in 1997 to that in 2003?
Ensure brevity in your answer.  1. What is the ratio of the General Parity Index (GPI) of OECD members in 1999 to that in 2000?
Offer a terse response. 1.01. What is the ratio of the General Parity Index (GPI) in East Asia (developing only) in 1999 to that in 2001?
Ensure brevity in your answer.  0.99. What is the ratio of the General Parity Index (GPI) in Qatar in 1999 to that in 2001?
Provide a short and direct response. 1.01. What is the ratio of the General Parity Index (GPI) of East Asia (developing only) in 1999 to that in 2002?
Offer a terse response. 0.99. What is the ratio of the General Parity Index (GPI) in OECD members in 1999 to that in 2002?
Ensure brevity in your answer.  1. What is the ratio of the General Parity Index (GPI) of Qatar in 1999 to that in 2002?
Keep it short and to the point. 1.13. What is the ratio of the General Parity Index (GPI) of West Bank and Gaza in 1999 to that in 2002?
Your answer should be very brief. 1. What is the ratio of the General Parity Index (GPI) of East Asia (developing only) in 1999 to that in 2003?
Keep it short and to the point. 0.99. What is the ratio of the General Parity Index (GPI) of Qatar in 1999 to that in 2003?
Keep it short and to the point. 1.19. What is the ratio of the General Parity Index (GPI) in West Bank and Gaza in 1999 to that in 2003?
Provide a short and direct response. 1. What is the ratio of the General Parity Index (GPI) of OECD members in 2000 to that in 2001?
Make the answer very short. 0.99. What is the ratio of the General Parity Index (GPI) in Qatar in 2000 to that in 2001?
Keep it short and to the point. 1.01. What is the ratio of the General Parity Index (GPI) in West Bank and Gaza in 2000 to that in 2001?
Offer a very short reply. 0.99. What is the ratio of the General Parity Index (GPI) in OECD members in 2000 to that in 2002?
Your response must be concise. 0.99. What is the ratio of the General Parity Index (GPI) of Qatar in 2000 to that in 2002?
Your response must be concise. 1.13. What is the ratio of the General Parity Index (GPI) of West Bank and Gaza in 2000 to that in 2002?
Offer a terse response. 1. What is the ratio of the General Parity Index (GPI) of OECD members in 2000 to that in 2003?
Give a very brief answer. 0.99. What is the ratio of the General Parity Index (GPI) in Qatar in 2000 to that in 2003?
Your answer should be very brief. 1.19. What is the ratio of the General Parity Index (GPI) of East Asia (developing only) in 2001 to that in 2002?
Your response must be concise. 1. What is the ratio of the General Parity Index (GPI) of Qatar in 2001 to that in 2002?
Ensure brevity in your answer.  1.12. What is the ratio of the General Parity Index (GPI) in West Bank and Gaza in 2001 to that in 2002?
Give a very brief answer. 1. What is the ratio of the General Parity Index (GPI) in OECD members in 2001 to that in 2003?
Your answer should be compact. 1. What is the ratio of the General Parity Index (GPI) of Qatar in 2001 to that in 2003?
Offer a terse response. 1.18. What is the ratio of the General Parity Index (GPI) in Qatar in 2002 to that in 2003?
Offer a terse response. 1.05. What is the ratio of the General Parity Index (GPI) in West Bank and Gaza in 2002 to that in 2003?
Give a very brief answer. 1. What is the difference between the highest and the second highest General Parity Index (GPI) in East Asia (developing only)?
Keep it short and to the point. 0. What is the difference between the highest and the second highest General Parity Index (GPI) of OECD members?
Keep it short and to the point. 0. What is the difference between the highest and the second highest General Parity Index (GPI) in Qatar?
Give a very brief answer. 0.02. What is the difference between the highest and the second highest General Parity Index (GPI) of West Bank and Gaza?
Ensure brevity in your answer.  0. What is the difference between the highest and the lowest General Parity Index (GPI) in East Asia (developing only)?
Your answer should be compact. 0.03. What is the difference between the highest and the lowest General Parity Index (GPI) in OECD members?
Offer a terse response. 0.01. What is the difference between the highest and the lowest General Parity Index (GPI) in Qatar?
Offer a terse response. 0.19. What is the difference between the highest and the lowest General Parity Index (GPI) in West Bank and Gaza?
Your answer should be compact. 0.01. 